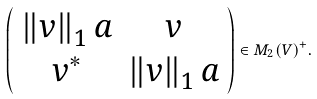Convert formula to latex. <formula><loc_0><loc_0><loc_500><loc_500>\left ( \begin{array} { c c } \left \| v \right \| _ { 1 } a & v \\ v ^ { * } & \left \| v \right \| _ { 1 } a \end{array} \right ) \in M _ { 2 } ( V ) ^ { + } .</formula> 